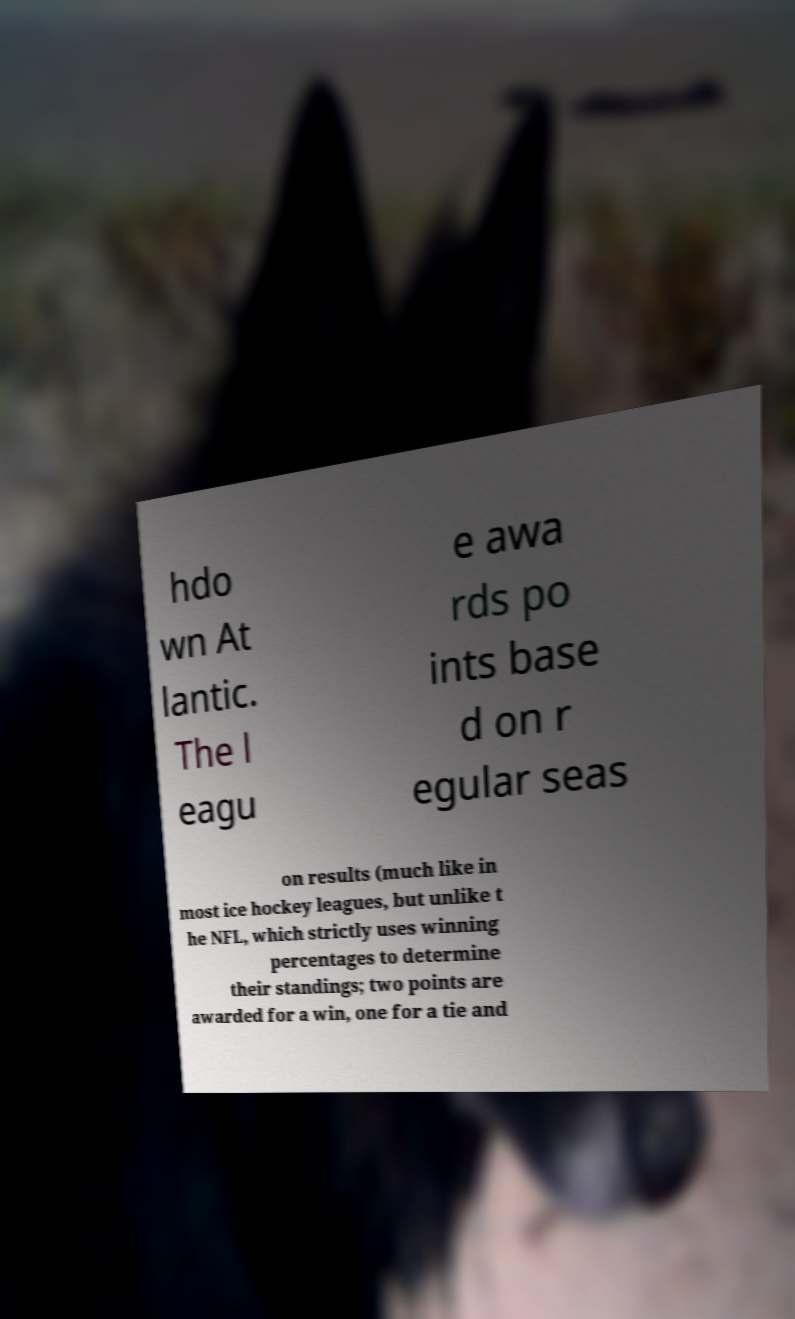Can you read and provide the text displayed in the image?This photo seems to have some interesting text. Can you extract and type it out for me? hdo wn At lantic. The l eagu e awa rds po ints base d on r egular seas on results (much like in most ice hockey leagues, but unlike t he NFL, which strictly uses winning percentages to determine their standings; two points are awarded for a win, one for a tie and 